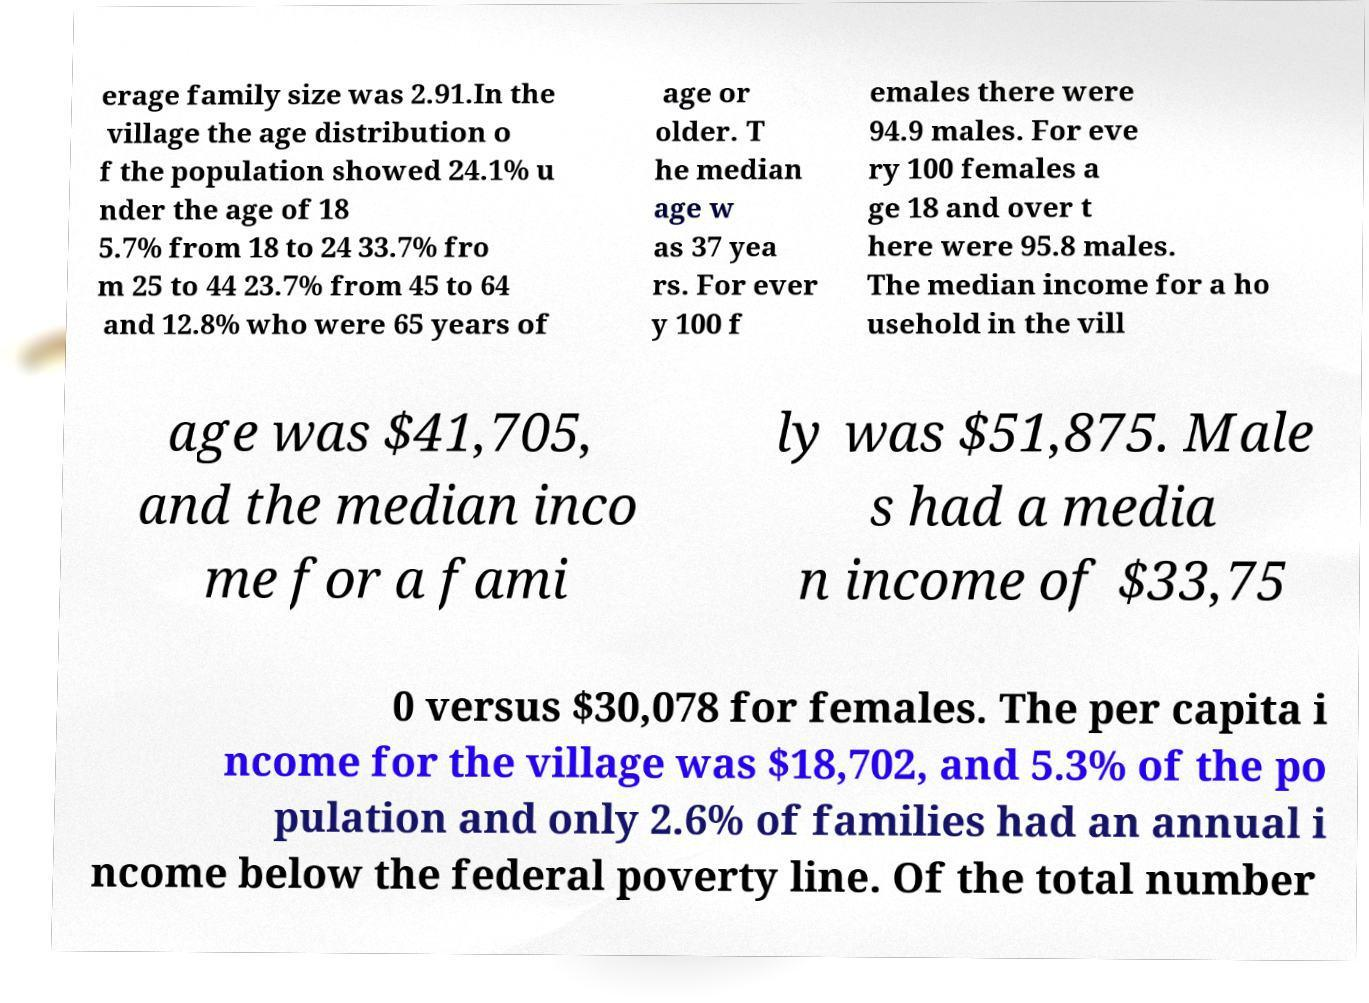Could you extract and type out the text from this image? erage family size was 2.91.In the village the age distribution o f the population showed 24.1% u nder the age of 18 5.7% from 18 to 24 33.7% fro m 25 to 44 23.7% from 45 to 64 and 12.8% who were 65 years of age or older. T he median age w as 37 yea rs. For ever y 100 f emales there were 94.9 males. For eve ry 100 females a ge 18 and over t here were 95.8 males. The median income for a ho usehold in the vill age was $41,705, and the median inco me for a fami ly was $51,875. Male s had a media n income of $33,75 0 versus $30,078 for females. The per capita i ncome for the village was $18,702, and 5.3% of the po pulation and only 2.6% of families had an annual i ncome below the federal poverty line. Of the total number 